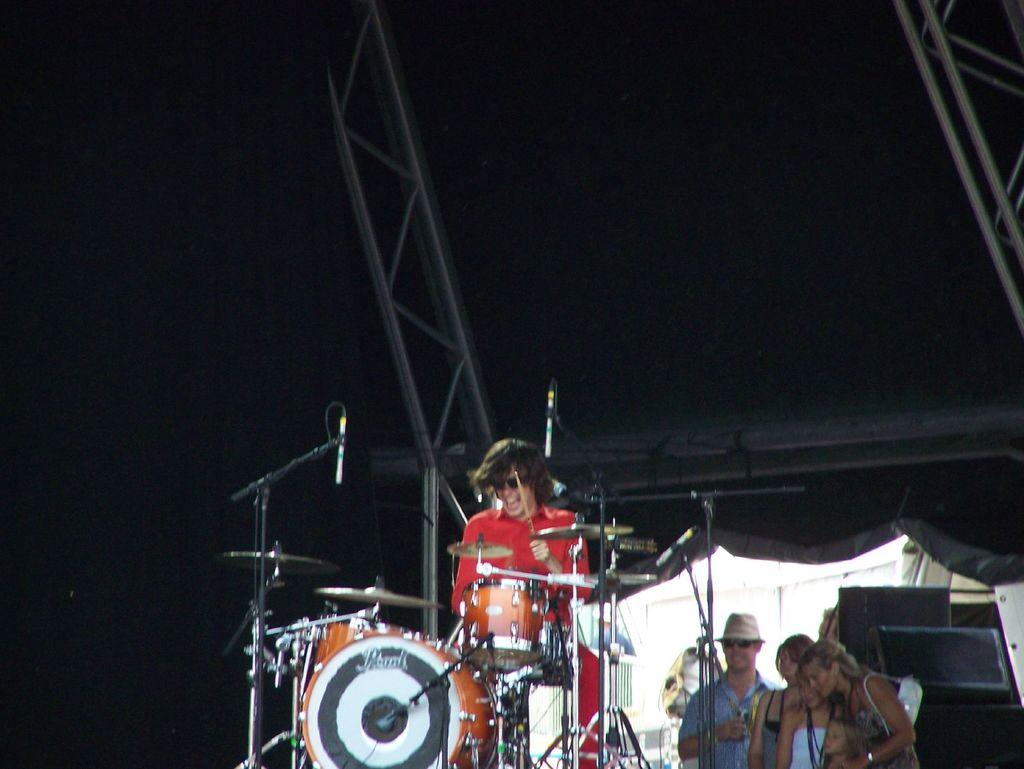What is happening on the stage in the image? There is a person on the stage, and they are playing a musical instrument. Can you describe the people behind the person on the stage? There are three people behind the person on the stage. What type of net is being used by the person on the stage? There is no net present in the image; the person is playing a musical instrument. 